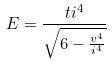<formula> <loc_0><loc_0><loc_500><loc_500>E = \frac { t i ^ { 4 } } { \sqrt { 6 - \frac { v ^ { 4 } } { i ^ { 4 } } } }</formula> 